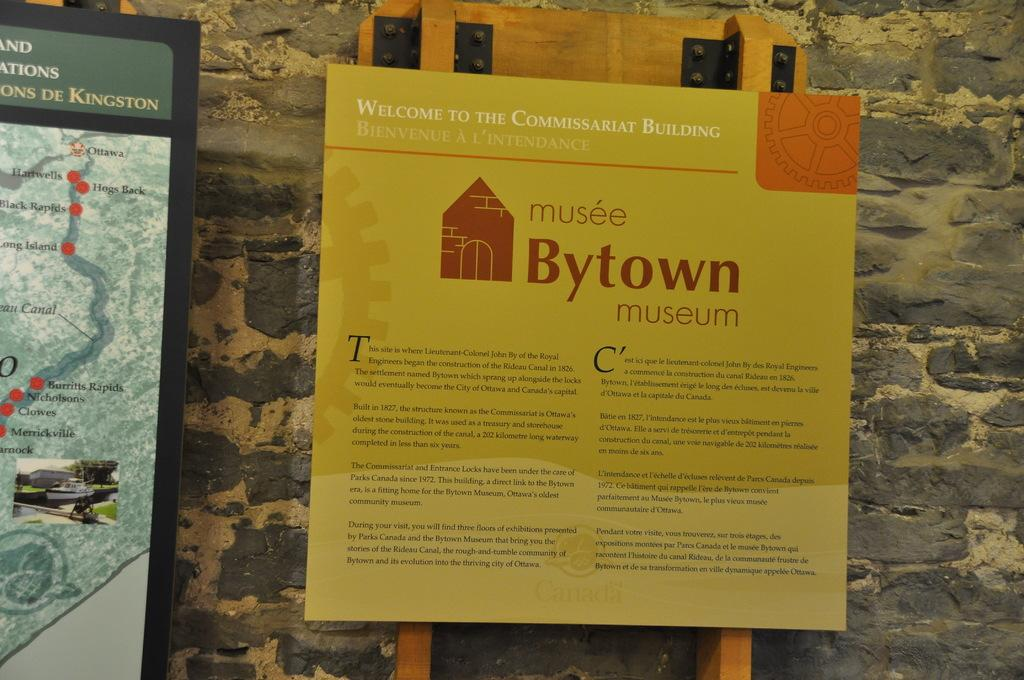<image>
Relay a brief, clear account of the picture shown. Sign at the Commissariat Building, featuring informtion about the Bytown museum. 